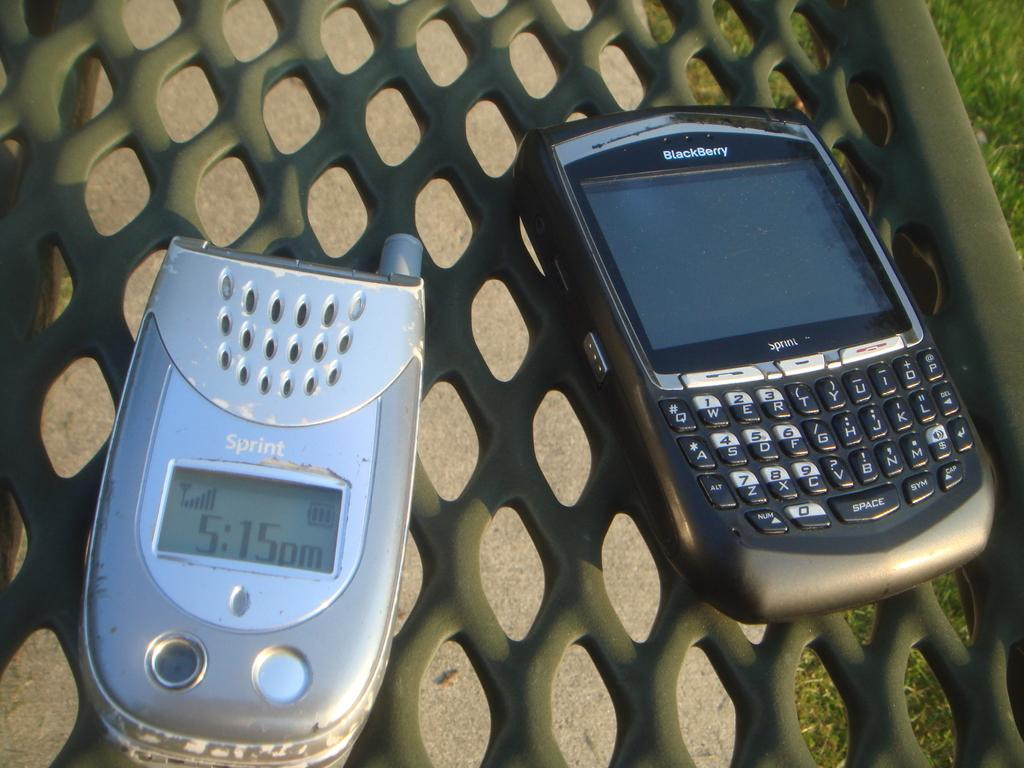<image>
Provide a brief description of the given image. A flip phone that says Sprint and a smartphone that says Blackberry is next to it on a bench. 